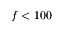<formula> <loc_0><loc_0><loc_500><loc_500>f < 1 0 0</formula> 